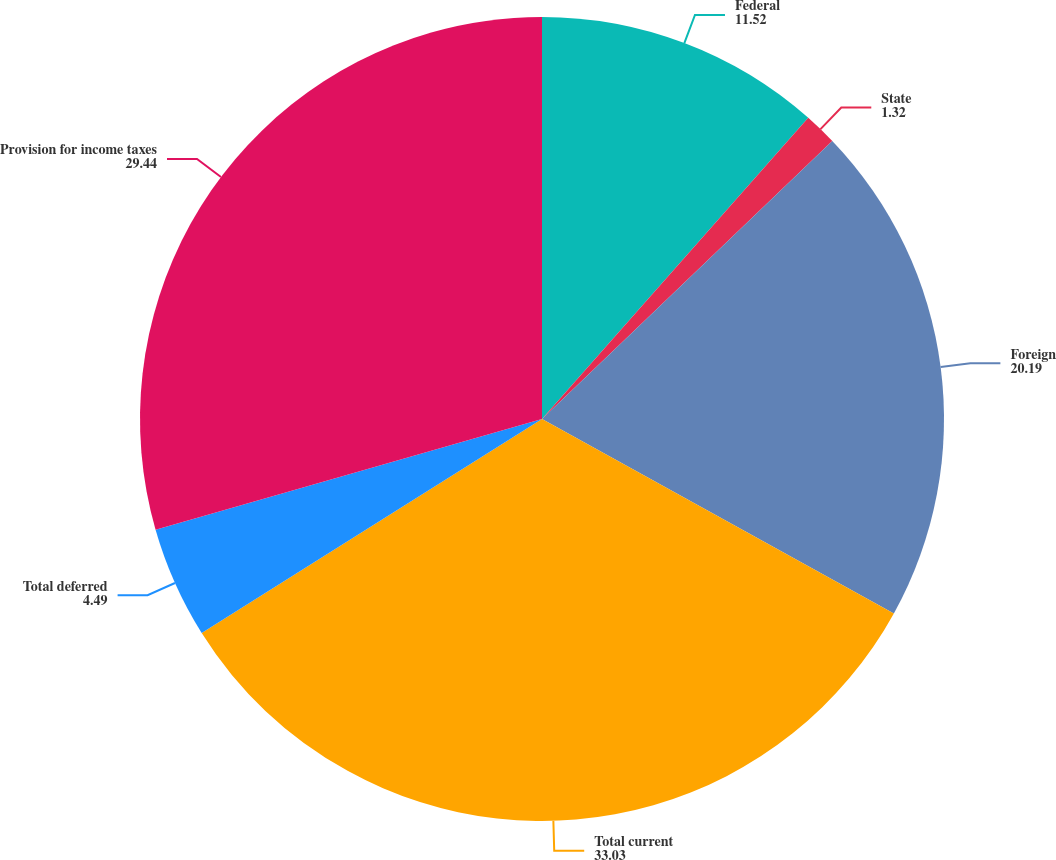<chart> <loc_0><loc_0><loc_500><loc_500><pie_chart><fcel>Federal<fcel>State<fcel>Foreign<fcel>Total current<fcel>Total deferred<fcel>Provision for income taxes<nl><fcel>11.52%<fcel>1.32%<fcel>20.19%<fcel>33.03%<fcel>4.49%<fcel>29.44%<nl></chart> 